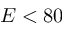<formula> <loc_0><loc_0><loc_500><loc_500>E < 8 0</formula> 